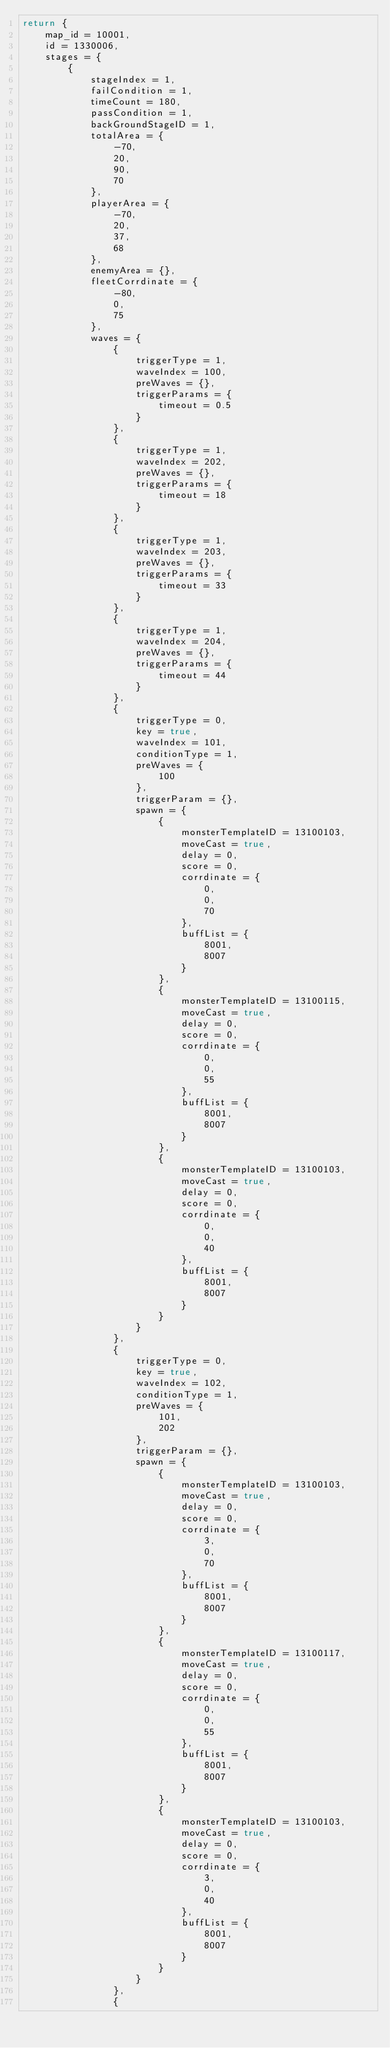<code> <loc_0><loc_0><loc_500><loc_500><_Lua_>return {
	map_id = 10001,
	id = 1330006,
	stages = {
		{
			stageIndex = 1,
			failCondition = 1,
			timeCount = 180,
			passCondition = 1,
			backGroundStageID = 1,
			totalArea = {
				-70,
				20,
				90,
				70
			},
			playerArea = {
				-70,
				20,
				37,
				68
			},
			enemyArea = {},
			fleetCorrdinate = {
				-80,
				0,
				75
			},
			waves = {
				{
					triggerType = 1,
					waveIndex = 100,
					preWaves = {},
					triggerParams = {
						timeout = 0.5
					}
				},
				{
					triggerType = 1,
					waveIndex = 202,
					preWaves = {},
					triggerParams = {
						timeout = 18
					}
				},
				{
					triggerType = 1,
					waveIndex = 203,
					preWaves = {},
					triggerParams = {
						timeout = 33
					}
				},
				{
					triggerType = 1,
					waveIndex = 204,
					preWaves = {},
					triggerParams = {
						timeout = 44
					}
				},
				{
					triggerType = 0,
					key = true,
					waveIndex = 101,
					conditionType = 1,
					preWaves = {
						100
					},
					triggerParam = {},
					spawn = {
						{
							monsterTemplateID = 13100103,
							moveCast = true,
							delay = 0,
							score = 0,
							corrdinate = {
								0,
								0,
								70
							},
							buffList = {
								8001,
								8007
							}
						},
						{
							monsterTemplateID = 13100115,
							moveCast = true,
							delay = 0,
							score = 0,
							corrdinate = {
								0,
								0,
								55
							},
							buffList = {
								8001,
								8007
							}
						},
						{
							monsterTemplateID = 13100103,
							moveCast = true,
							delay = 0,
							score = 0,
							corrdinate = {
								0,
								0,
								40
							},
							buffList = {
								8001,
								8007
							}
						}
					}
				},
				{
					triggerType = 0,
					key = true,
					waveIndex = 102,
					conditionType = 1,
					preWaves = {
						101,
						202
					},
					triggerParam = {},
					spawn = {
						{
							monsterTemplateID = 13100103,
							moveCast = true,
							delay = 0,
							score = 0,
							corrdinate = {
								3,
								0,
								70
							},
							buffList = {
								8001,
								8007
							}
						},
						{
							monsterTemplateID = 13100117,
							moveCast = true,
							delay = 0,
							score = 0,
							corrdinate = {
								0,
								0,
								55
							},
							buffList = {
								8001,
								8007
							}
						},
						{
							monsterTemplateID = 13100103,
							moveCast = true,
							delay = 0,
							score = 0,
							corrdinate = {
								3,
								0,
								40
							},
							buffList = {
								8001,
								8007
							}
						}
					}
				},
				{</code> 